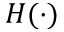Convert formula to latex. <formula><loc_0><loc_0><loc_500><loc_500>H ( \cdot )</formula> 